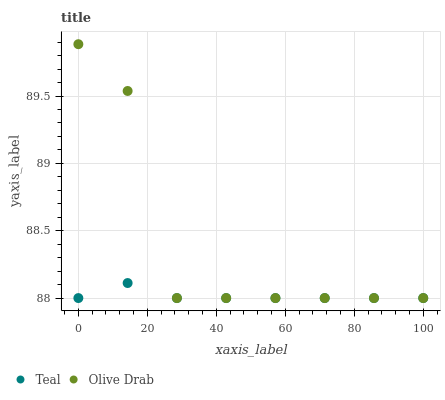Does Teal have the minimum area under the curve?
Answer yes or no. Yes. Does Olive Drab have the maximum area under the curve?
Answer yes or no. Yes. Does Teal have the maximum area under the curve?
Answer yes or no. No. Is Teal the smoothest?
Answer yes or no. Yes. Is Olive Drab the roughest?
Answer yes or no. Yes. Is Teal the roughest?
Answer yes or no. No. Does Olive Drab have the lowest value?
Answer yes or no. Yes. Does Olive Drab have the highest value?
Answer yes or no. Yes. Does Teal have the highest value?
Answer yes or no. No. Does Olive Drab intersect Teal?
Answer yes or no. Yes. Is Olive Drab less than Teal?
Answer yes or no. No. Is Olive Drab greater than Teal?
Answer yes or no. No. 